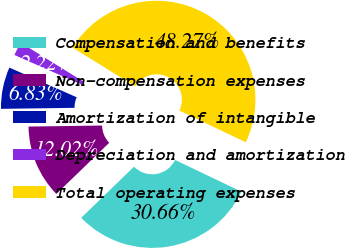Convert chart to OTSL. <chart><loc_0><loc_0><loc_500><loc_500><pie_chart><fcel>Compensation and benefits<fcel>Non-compensation expenses<fcel>Amortization of intangible<fcel>Depreciation and amortization<fcel>Total operating expenses<nl><fcel>30.66%<fcel>12.02%<fcel>6.83%<fcel>2.22%<fcel>48.27%<nl></chart> 